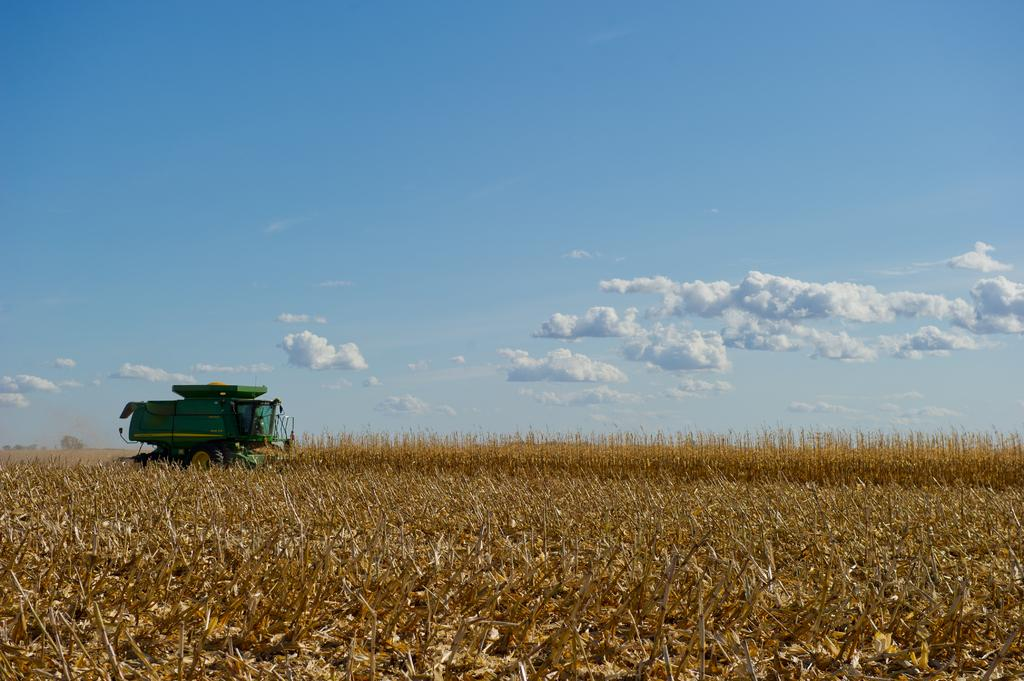What type of vegetation is at the bottom of the image? There are plants at the bottom of the image. What is located in the middle of the image? There is a vehicle in the middle of the image. What is visible at the top of the image? The sky is visible at the top of the image. What can be seen in the sky? Clouds are present in the sky. What type of class is being held in the image? There is no class present in the image; it features plants, a vehicle, and clouds in the sky. What event is taking place in the image? There is no specific event depicted in the image; it shows a scene with plants, a vehicle, and clouds in the sky. 